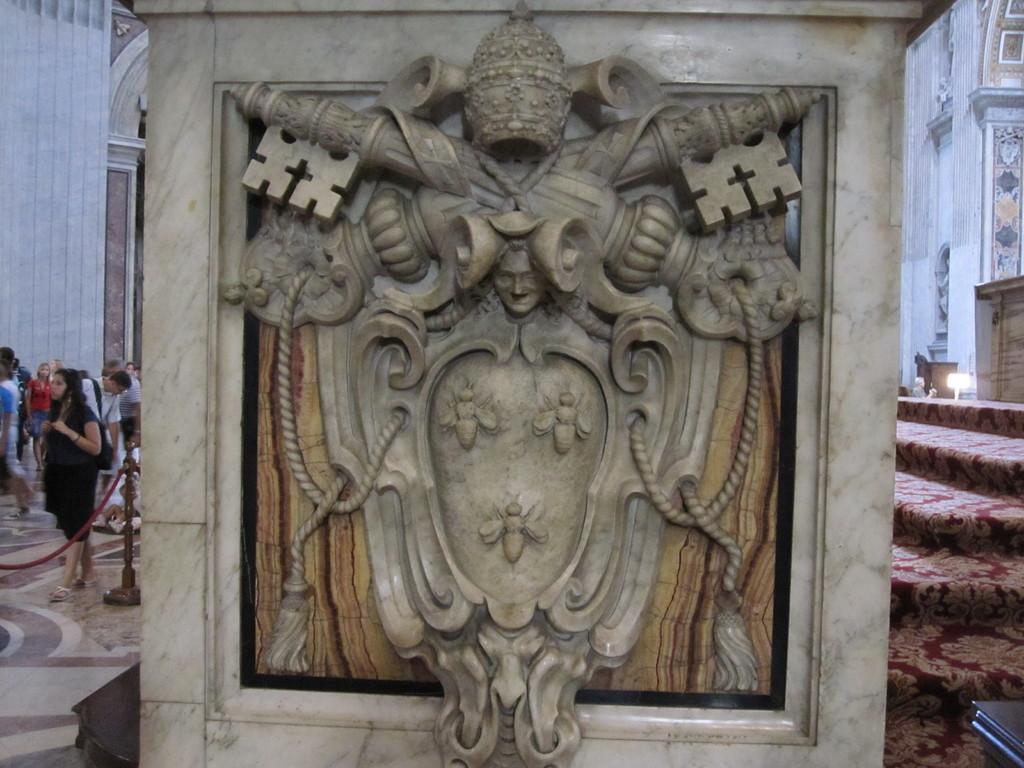Could you give a brief overview of what you see in this image? Here in this picture, in the middle we can see a statue carved on a stone, that is present on the ground and behind that we can see number of people standing and walking on the floor and we can also see ropes hanging around it and we can see other monumental buildings present behind that. 